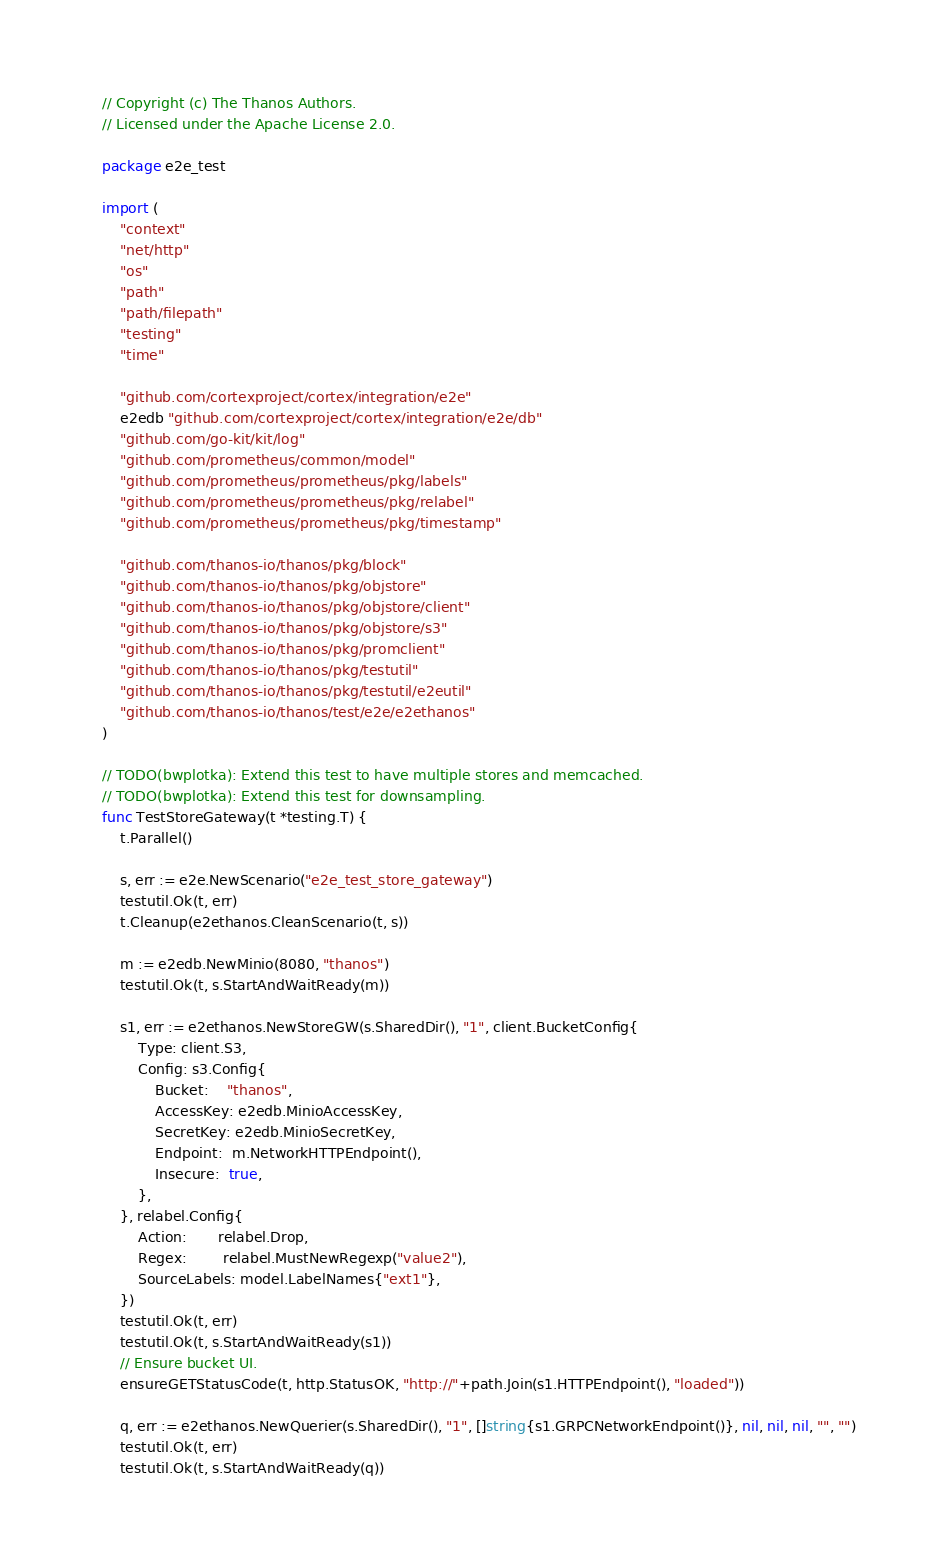<code> <loc_0><loc_0><loc_500><loc_500><_Go_>// Copyright (c) The Thanos Authors.
// Licensed under the Apache License 2.0.

package e2e_test

import (
	"context"
	"net/http"
	"os"
	"path"
	"path/filepath"
	"testing"
	"time"

	"github.com/cortexproject/cortex/integration/e2e"
	e2edb "github.com/cortexproject/cortex/integration/e2e/db"
	"github.com/go-kit/kit/log"
	"github.com/prometheus/common/model"
	"github.com/prometheus/prometheus/pkg/labels"
	"github.com/prometheus/prometheus/pkg/relabel"
	"github.com/prometheus/prometheus/pkg/timestamp"

	"github.com/thanos-io/thanos/pkg/block"
	"github.com/thanos-io/thanos/pkg/objstore"
	"github.com/thanos-io/thanos/pkg/objstore/client"
	"github.com/thanos-io/thanos/pkg/objstore/s3"
	"github.com/thanos-io/thanos/pkg/promclient"
	"github.com/thanos-io/thanos/pkg/testutil"
	"github.com/thanos-io/thanos/pkg/testutil/e2eutil"
	"github.com/thanos-io/thanos/test/e2e/e2ethanos"
)

// TODO(bwplotka): Extend this test to have multiple stores and memcached.
// TODO(bwplotka): Extend this test for downsampling.
func TestStoreGateway(t *testing.T) {
	t.Parallel()

	s, err := e2e.NewScenario("e2e_test_store_gateway")
	testutil.Ok(t, err)
	t.Cleanup(e2ethanos.CleanScenario(t, s))

	m := e2edb.NewMinio(8080, "thanos")
	testutil.Ok(t, s.StartAndWaitReady(m))

	s1, err := e2ethanos.NewStoreGW(s.SharedDir(), "1", client.BucketConfig{
		Type: client.S3,
		Config: s3.Config{
			Bucket:    "thanos",
			AccessKey: e2edb.MinioAccessKey,
			SecretKey: e2edb.MinioSecretKey,
			Endpoint:  m.NetworkHTTPEndpoint(),
			Insecure:  true,
		},
	}, relabel.Config{
		Action:       relabel.Drop,
		Regex:        relabel.MustNewRegexp("value2"),
		SourceLabels: model.LabelNames{"ext1"},
	})
	testutil.Ok(t, err)
	testutil.Ok(t, s.StartAndWaitReady(s1))
	// Ensure bucket UI.
	ensureGETStatusCode(t, http.StatusOK, "http://"+path.Join(s1.HTTPEndpoint(), "loaded"))

	q, err := e2ethanos.NewQuerier(s.SharedDir(), "1", []string{s1.GRPCNetworkEndpoint()}, nil, nil, nil, "", "")
	testutil.Ok(t, err)
	testutil.Ok(t, s.StartAndWaitReady(q))
</code> 